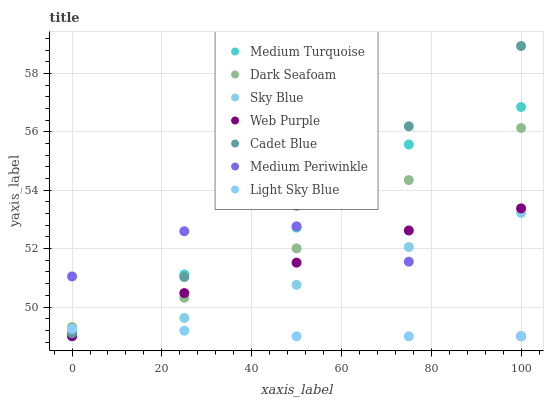Does Light Sky Blue have the minimum area under the curve?
Answer yes or no. Yes. Does Cadet Blue have the maximum area under the curve?
Answer yes or no. Yes. Does Medium Periwinkle have the minimum area under the curve?
Answer yes or no. No. Does Medium Periwinkle have the maximum area under the curve?
Answer yes or no. No. Is Light Sky Blue the smoothest?
Answer yes or no. Yes. Is Medium Periwinkle the roughest?
Answer yes or no. Yes. Is Web Purple the smoothest?
Answer yes or no. No. Is Web Purple the roughest?
Answer yes or no. No. Does Medium Periwinkle have the lowest value?
Answer yes or no. Yes. Does Dark Seafoam have the lowest value?
Answer yes or no. No. Does Cadet Blue have the highest value?
Answer yes or no. Yes. Does Medium Periwinkle have the highest value?
Answer yes or no. No. Is Light Sky Blue less than Dark Seafoam?
Answer yes or no. Yes. Is Dark Seafoam greater than Light Sky Blue?
Answer yes or no. Yes. Does Light Sky Blue intersect Cadet Blue?
Answer yes or no. Yes. Is Light Sky Blue less than Cadet Blue?
Answer yes or no. No. Is Light Sky Blue greater than Cadet Blue?
Answer yes or no. No. Does Light Sky Blue intersect Dark Seafoam?
Answer yes or no. No. 